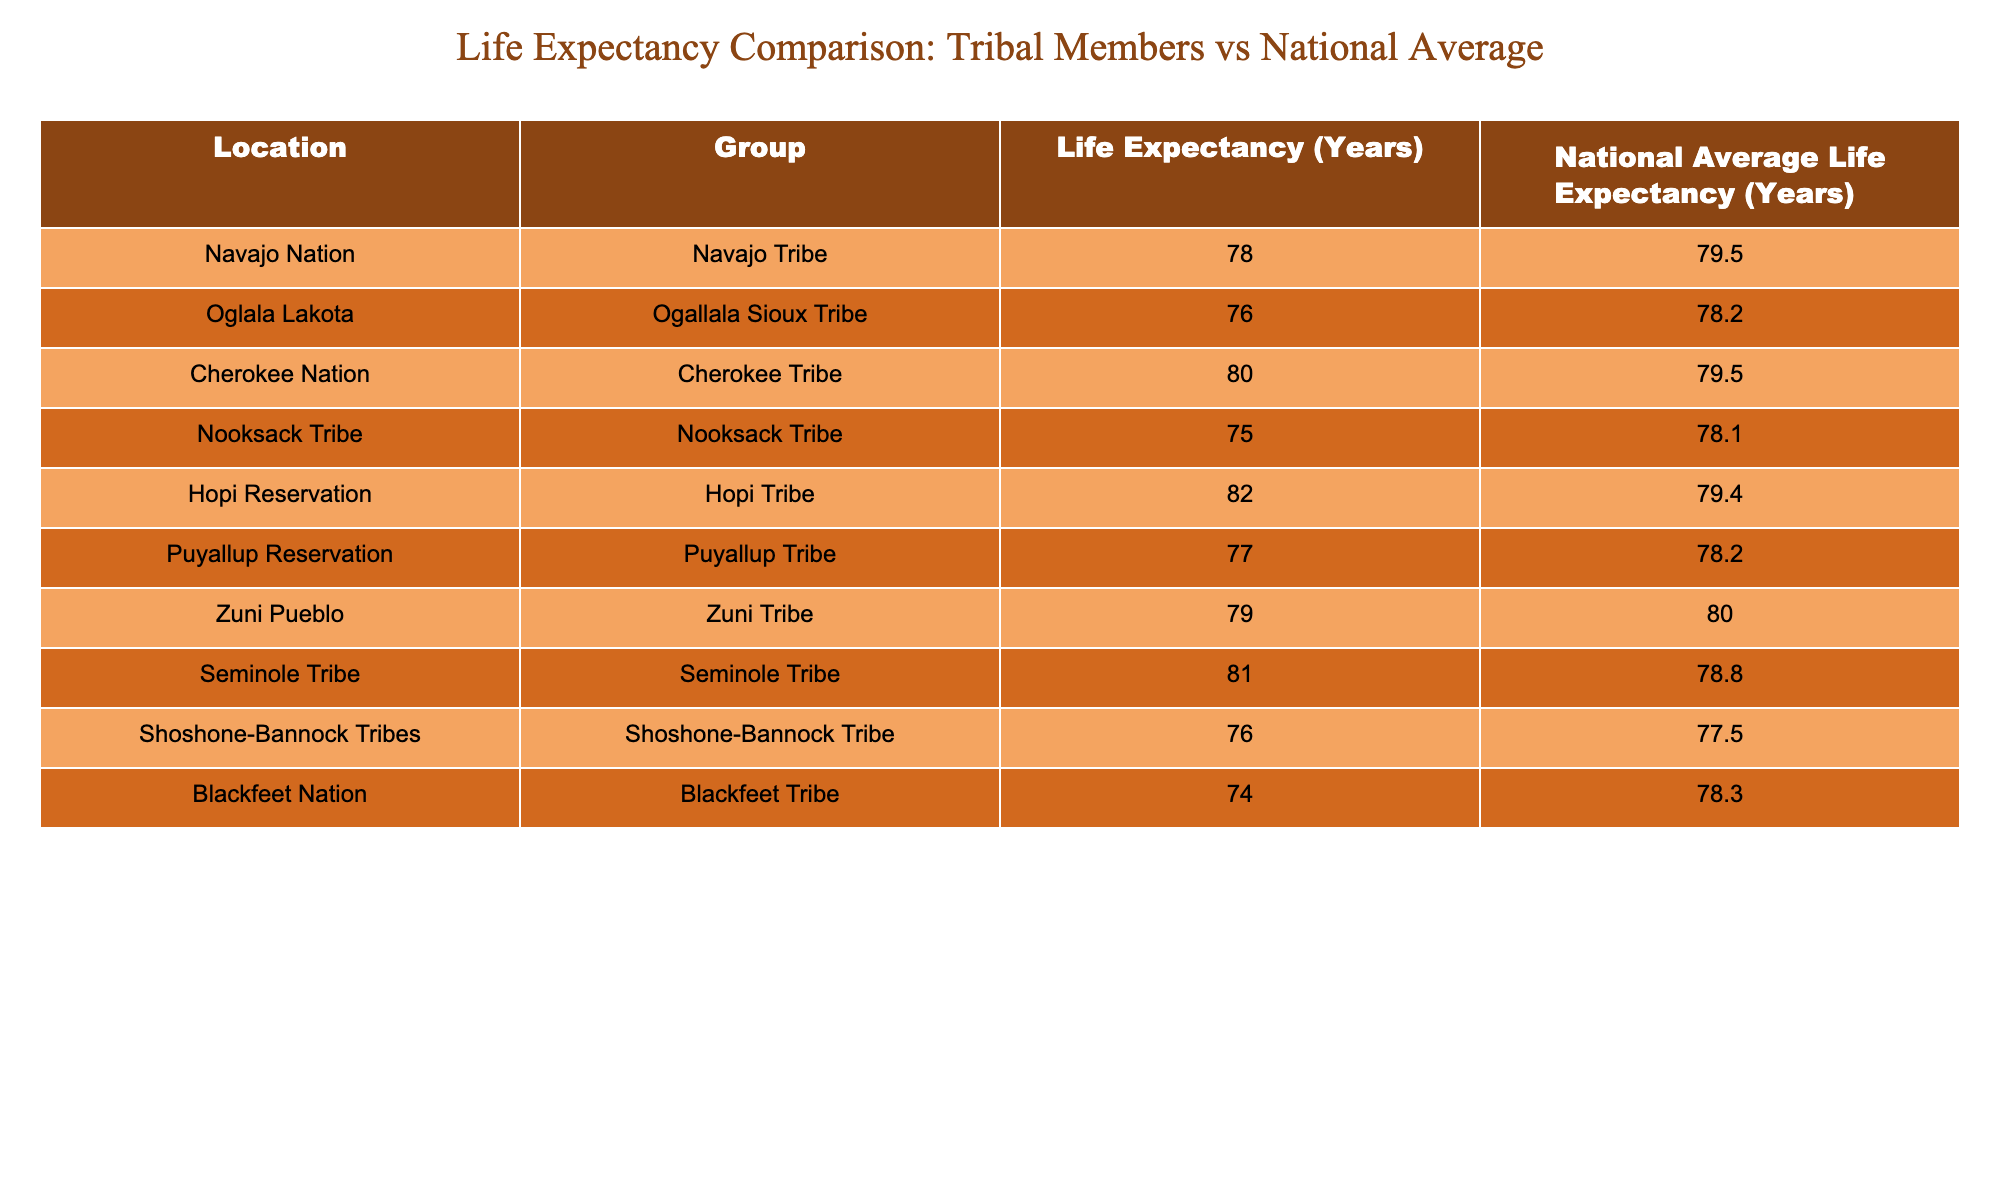What is the life expectancy of the Puyallup Tribe? The life expectancy for the Puyallup Tribe is listed directly in the table under the "Life Expectancy (Years)" column for the corresponding row. It shows 77 years.
Answer: 77 Which tribe has the highest life expectancy? By reviewing the Life Expectancy (Years) column, the Hopi Tribe has the highest value at 82 years.
Answer: 82 What is the difference between the life expectancy of the Cherokee Tribe and the national average for the Cherokee Nation? The life expectancy for the Cherokee Tribe is 80 years, and the national average is 79.5 years. To find the difference, we subtract: 80 - 79.5 = 0.5 years.
Answer: 0.5 years Does the life expectancy of the Navajo Tribe meet or exceed the national average for their group? The life expectancy of the Navajo Tribe is 78 years, while the national average is 79.5 years. Since 78 is less than 79.5, the answer is no.
Answer: No What is the average life expectancy for all the tribes listed in the table? To calculate the average, we first sum the life expectancies: 78 + 76 + 80 + 75 + 82 + 77 + 79 + 81 + 76 + 74 =  783 years. There are 10 tribes, so we divide: 783 / 10 = 78.3 years.
Answer: 78.3 years Which tribe has a life expectancy higher than the national average? By comparing each tribe's life expectancy to the national average, the tribes with higher life expectancy values are the Hopi Tribe (82) and the Seminole Tribe (81).
Answer: Hopi Tribe and Seminole Tribe Is the life expectancy of the Oglala Lakota below the national average? The life expectancy for the Oglala Lakota is 76 years, which is compared to the national average of 78.2 years. Since 76 is less than 78.2, the answer is yes.
Answer: Yes How many tribes have a life expectancy lower than 78 years? By examining each life expectancy, three tribes show values lower than 78 years: Nooksack Tribe (75), Blackfeet Tribe (74), and Oglala Lakota (76). Therefore, the total is three tribes.
Answer: 3 tribes Which tribal group has the closest life expectancy to the national average, and what is that expectancy? The Zuni Tribe has a life expectancy of 79 years while the national average is 80 years. The difference of 1 year shows that it's the closest, considering both are similar values compared to others.
Answer: Zuni Tribe, 79 years 